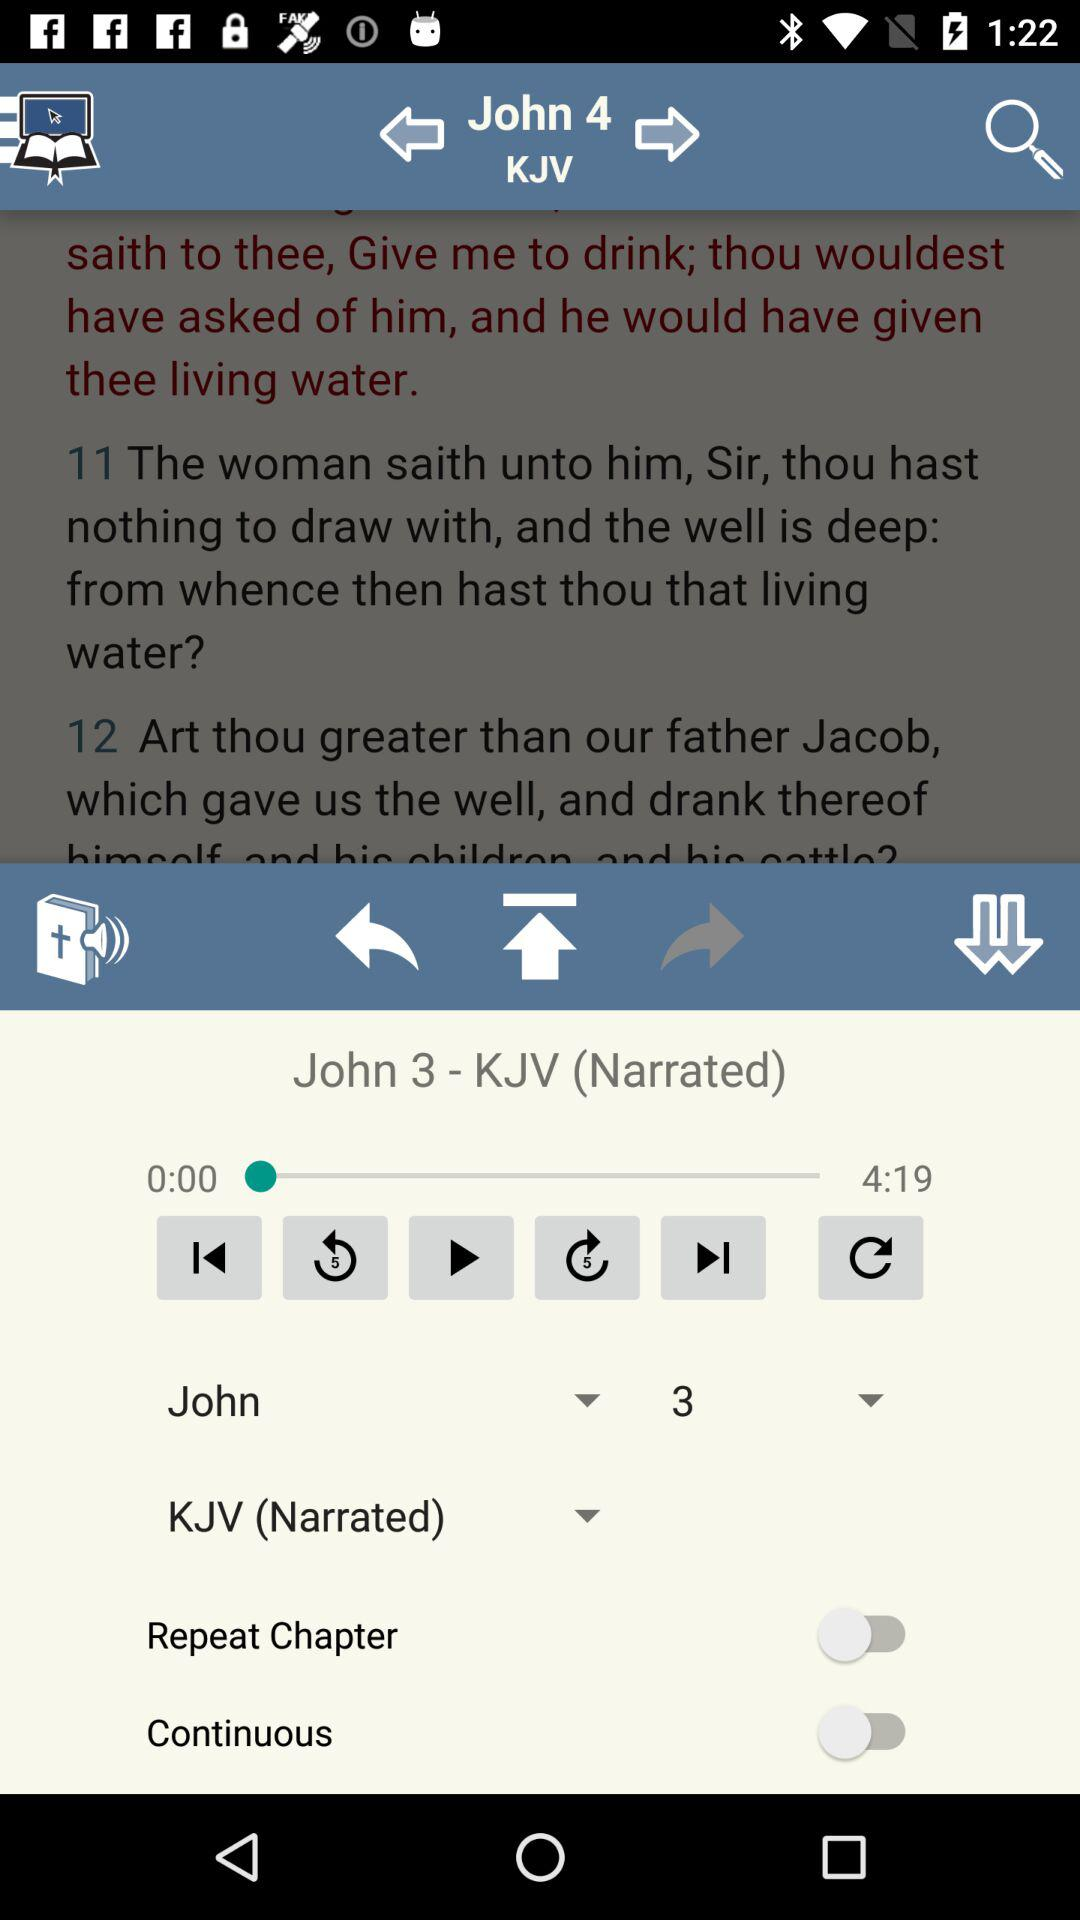What is the status of "Repeat Chapter"? The status of "Repeat Chapter" is "off". 